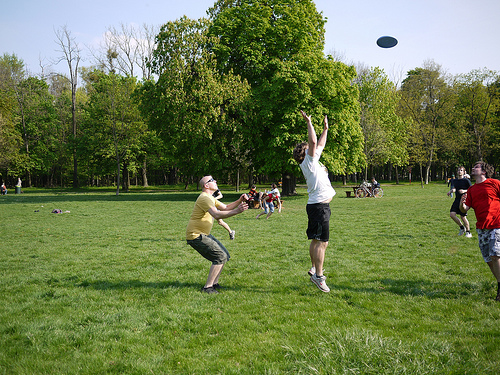Imagine a realistic scenario: What might the man in the white tank top do later in the day? The man in the white tank top might head home to shower and change after spending his day playing frisbee. He could then meet up with friends for dinner or unwind with some leisure activities like watching a movie or reading a book. What might be a short, realistic scenario for the group? After playing frisbee, the group might decide to visit a nearby café for some refreshments and light snacks. 